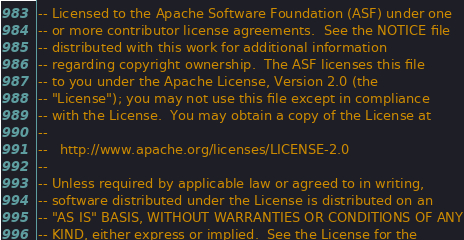<code> <loc_0><loc_0><loc_500><loc_500><_SQL_>-- Licensed to the Apache Software Foundation (ASF) under one
-- or more contributor license agreements.  See the NOTICE file
-- distributed with this work for additional information
-- regarding copyright ownership.  The ASF licenses this file
-- to you under the Apache License, Version 2.0 (the
-- "License"); you may not use this file except in compliance
-- with the License.  You may obtain a copy of the License at
--
--   http://www.apache.org/licenses/LICENSE-2.0
--
-- Unless required by applicable law or agreed to in writing,
-- software distributed under the License is distributed on an
-- "AS IS" BASIS, WITHOUT WARRANTIES OR CONDITIONS OF ANY
-- KIND, either express or implied.  See the License for the</code> 